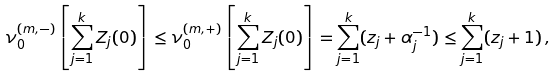<formula> <loc_0><loc_0><loc_500><loc_500>\nu _ { 0 } ^ { ( m , - ) } \left [ \sum _ { j = 1 } ^ { k } Z _ { j } ( 0 ) \right ] \leq \nu _ { 0 } ^ { ( m , + ) } \left [ \sum _ { j = 1 } ^ { k } Z _ { j } ( 0 ) \right ] = \sum _ { j = 1 } ^ { k } ( z _ { j } + \alpha _ { j } ^ { - 1 } ) \leq \sum _ { j = 1 } ^ { k } ( z _ { j } + 1 ) \, ,</formula> 